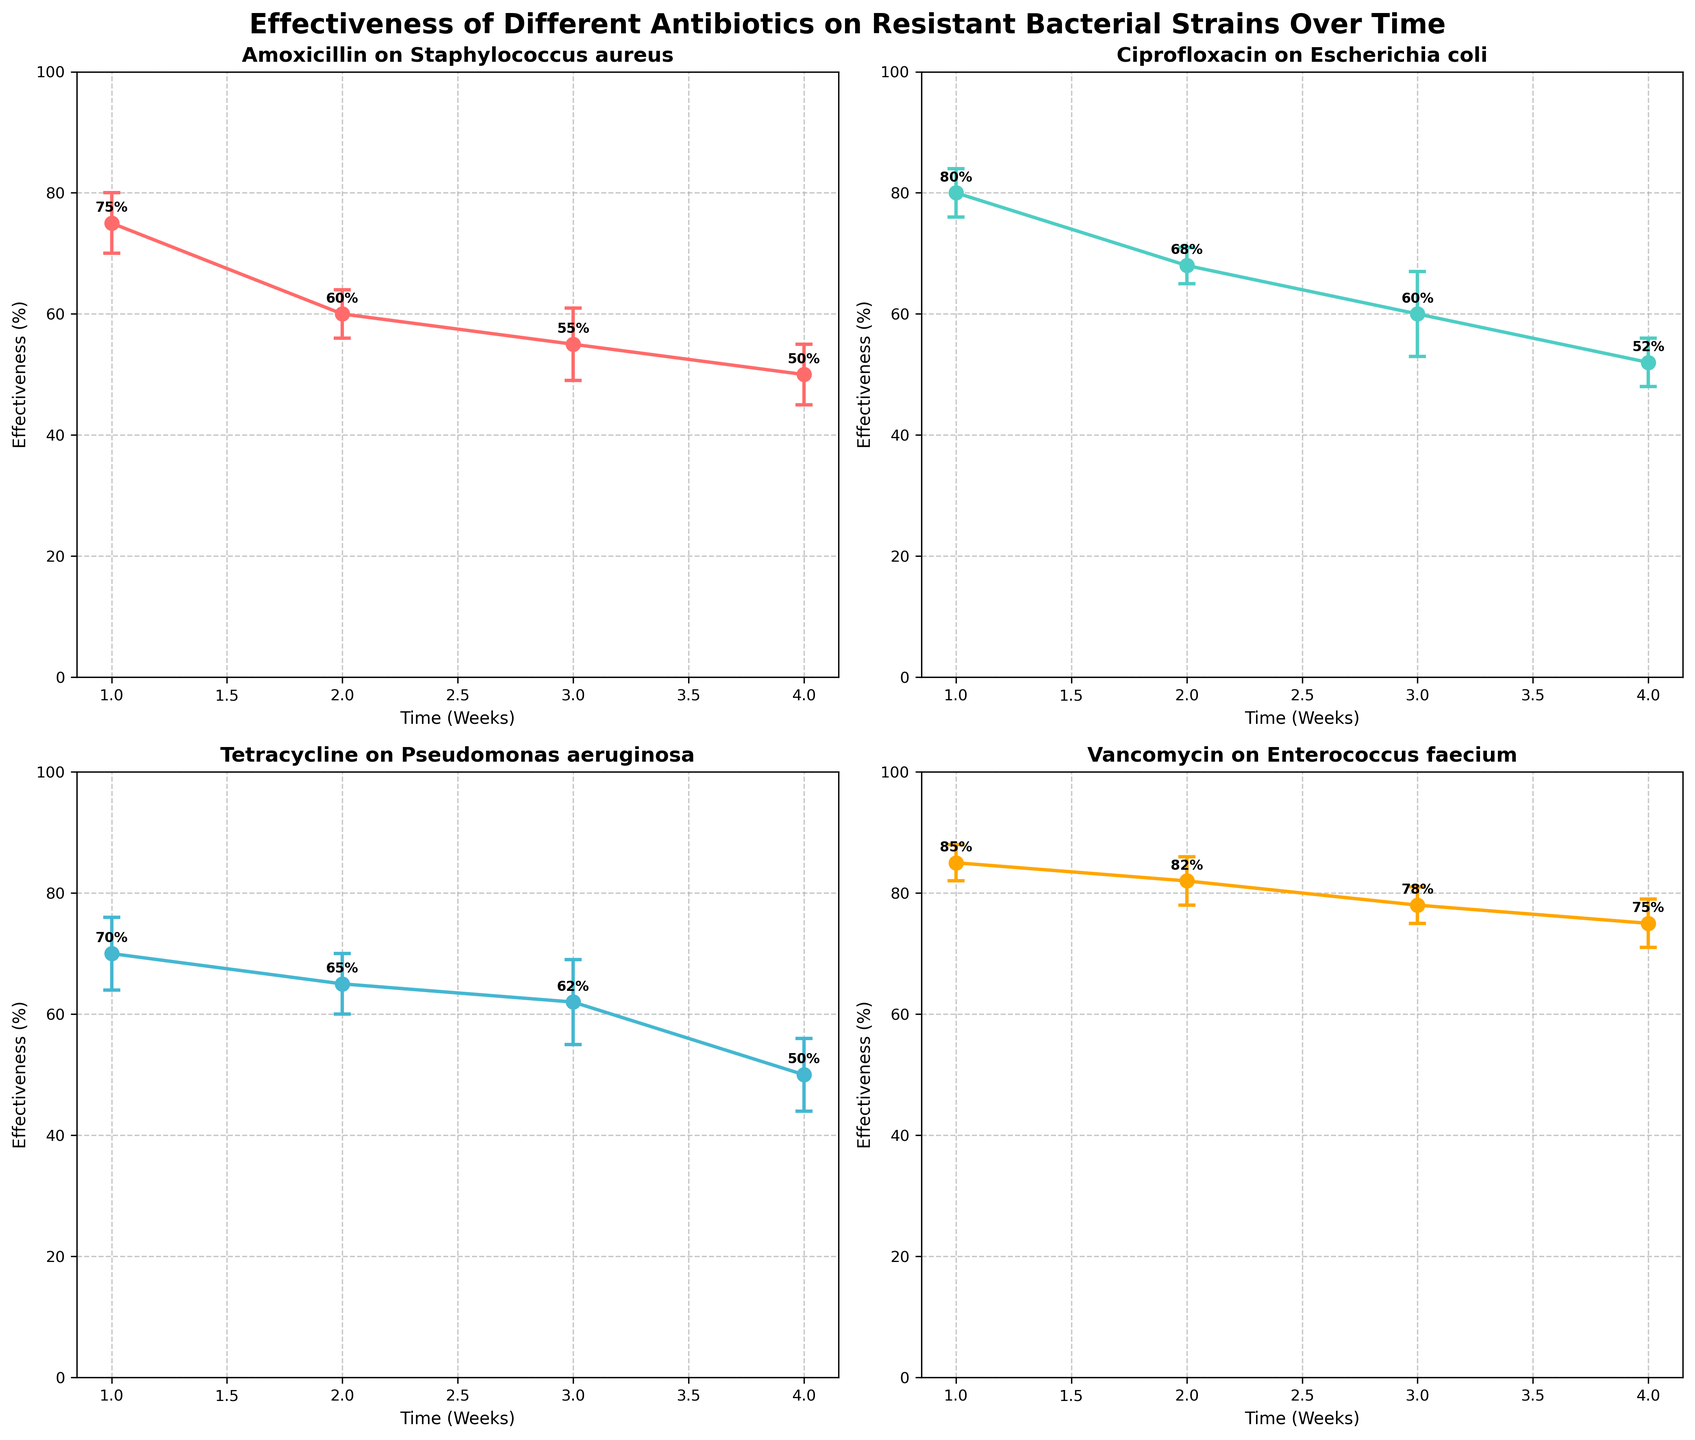Which bacterial strain is targeted by Ciprofloxacin? The subplot title for Ciprofloxacin indicates the bacterial strain it targets.
Answer: Escherichia coli How many time points are shown for each antibiotic? Each subplot shows data points for the weeks 1, 2, 3, and 4. Thus, there are 4 time points for each antibiotic.
Answer: 4 Which bacterial strain shows the least reduction in effectiveness over time for the given antibiotics? By closely examining the effectiveness trends, we observe that Pseudomonas aeruginosa, targeted by Tetracycline, shows a slower decline over the weeks compared to others.
Answer: Pseudomonas aeruginosa How does the reduction in effectiveness of Vancomycin on Enterococcus faecium change from Week 1 to Week 4? Look at the data points and error bars in the Vancomycin subplot. From Week 1 (85%) to Week 4 (75%), there is a reduction of 10%.
Answer: 10% Which antibiotic exhibits the most stable effectiveness over the four weeks, based on the error bars? Stability can be assessed by looking for the smallest error bars. Vancomycin's error bars appear relatively small and consistent across the four weeks.
Answer: Vancomycin What is the average effectiveness for Amoxicillin on Staphylococcus aureus over the four weeks? Sum the effectiveness percentages given for each week and divide by the number of weeks: (75 + 60 + 55 + 50)/4 = 60.
Answer: 60 Which antibiotic has the highest effectiveness in Week 1? Look at the Week 1 data points across all subplots. Vancomycin shows the highest effectiveness with 85%.
Answer: Vancomycin Compare the effectiveness of Ciprofloxacin and Tetracycline in Week 3. Which one is more effective? Check the Week 3 effectiveness values on their respective subplots: Ciprofloxacin (60%) and Tetracycline (62%). Tetracycline is slightly more effective.
Answer: Tetracycline What does an error bar represent in these subplots? Error bars represent the standard deviation among trials, indicating the variability or uncertainty of the effectiveness measurement.
Answer: Standard deviation By how much does the effectiveness of Tetracycline decrease from Week 2 to Week 4? From Week 2 (65%) to Week 4 (50%), the effectiveness of Tetracycline drops by 15%.
Answer: 15% 